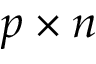Convert formula to latex. <formula><loc_0><loc_0><loc_500><loc_500>p \times n</formula> 